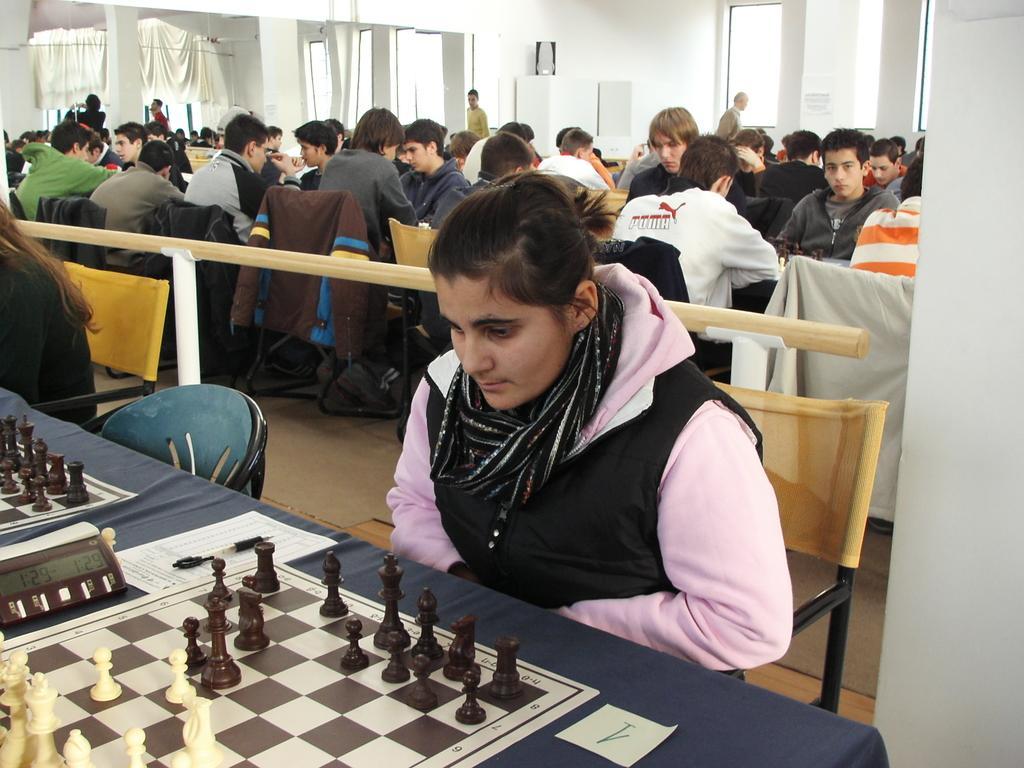Please provide a concise description of this image. As we can see in the image there is a white color wall, curtain, few people sitting on chairs and there is a table. On table there are chess board and coins and papers. 